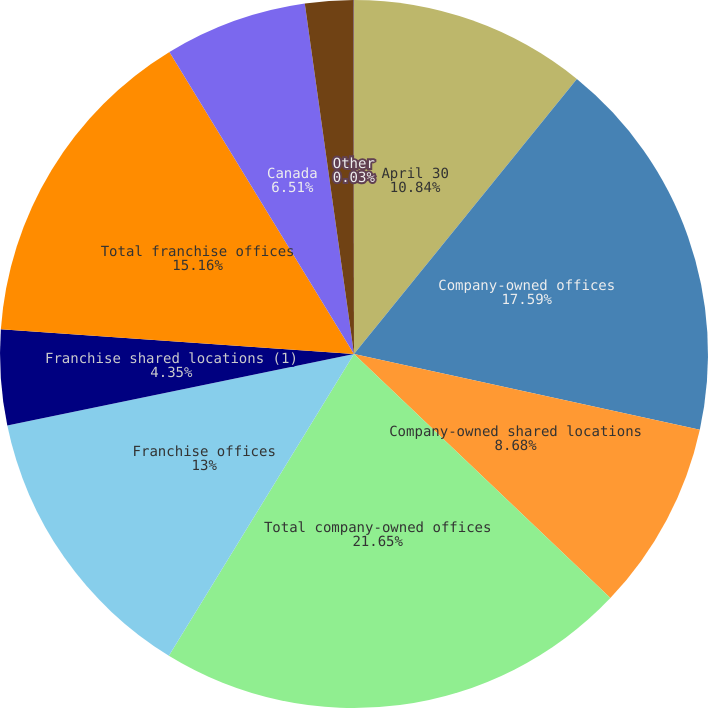Convert chart to OTSL. <chart><loc_0><loc_0><loc_500><loc_500><pie_chart><fcel>April 30<fcel>Company-owned offices<fcel>Company-owned shared locations<fcel>Total company-owned offices<fcel>Franchise offices<fcel>Franchise shared locations (1)<fcel>Total franchise offices<fcel>Canada<fcel>Australia<fcel>Other<nl><fcel>10.84%<fcel>17.59%<fcel>8.68%<fcel>21.65%<fcel>13.0%<fcel>4.35%<fcel>15.16%<fcel>6.51%<fcel>2.19%<fcel>0.03%<nl></chart> 